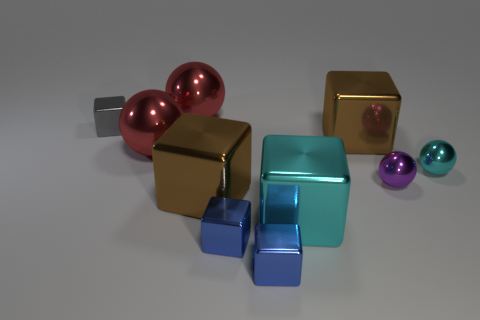There is a gray cube that is the same material as the big cyan block; what is its size?
Your response must be concise. Small. Is the number of cyan metal objects that are left of the big cyan cube greater than the number of big brown blocks?
Make the answer very short. No. There is a thing that is in front of the cyan metallic ball and right of the large cyan metal block; how big is it?
Keep it short and to the point. Small. What material is the cyan thing that is the same shape as the small purple thing?
Provide a short and direct response. Metal. Is the size of the shiny cube right of the cyan metallic cube the same as the tiny purple shiny sphere?
Give a very brief answer. No. What color is the sphere that is both left of the cyan metal cube and in front of the gray shiny cube?
Make the answer very short. Red. What number of tiny gray cubes are on the right side of the brown shiny object that is behind the purple ball?
Your answer should be very brief. 0. Is the shape of the purple metallic thing the same as the large cyan thing?
Ensure brevity in your answer.  No. There is a large cyan object; is it the same shape as the cyan object on the right side of the cyan cube?
Ensure brevity in your answer.  No. The big metallic block that is in front of the large brown cube that is in front of the large brown metal thing that is to the right of the cyan metallic block is what color?
Offer a terse response. Cyan. 